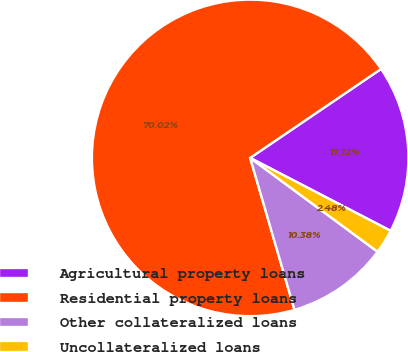<chart> <loc_0><loc_0><loc_500><loc_500><pie_chart><fcel>Agricultural property loans<fcel>Residential property loans<fcel>Other collateralized loans<fcel>Uncollateralized loans<nl><fcel>17.12%<fcel>70.02%<fcel>10.38%<fcel>2.48%<nl></chart> 